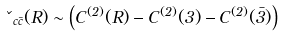Convert formula to latex. <formula><loc_0><loc_0><loc_500><loc_500>\kappa _ { c \bar { c } } ( { R } ) \sim \left ( C ^ { ( 2 ) } ( { R } ) - C ^ { ( 2 ) } ( { 3 } ) - C ^ { ( 2 ) } ( { \bar { 3 } } ) \right )</formula> 